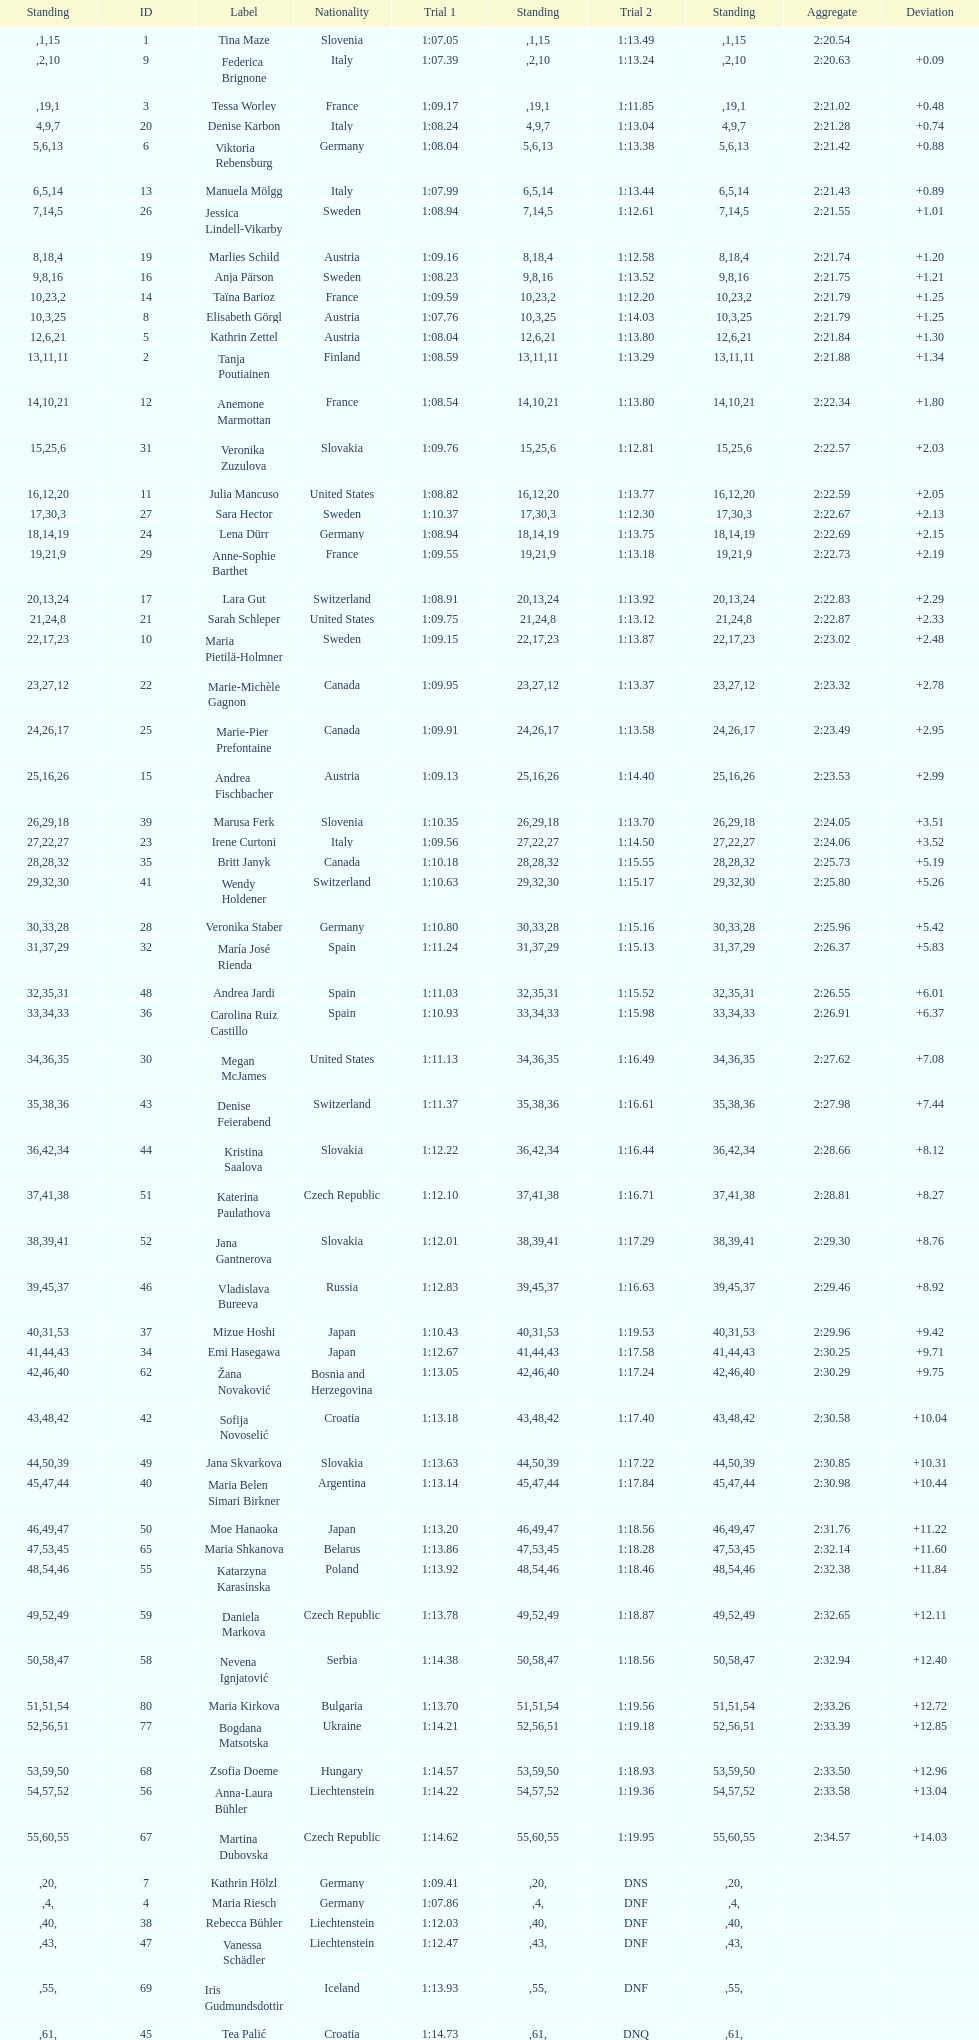How many italians finished in the top ten? 3. 